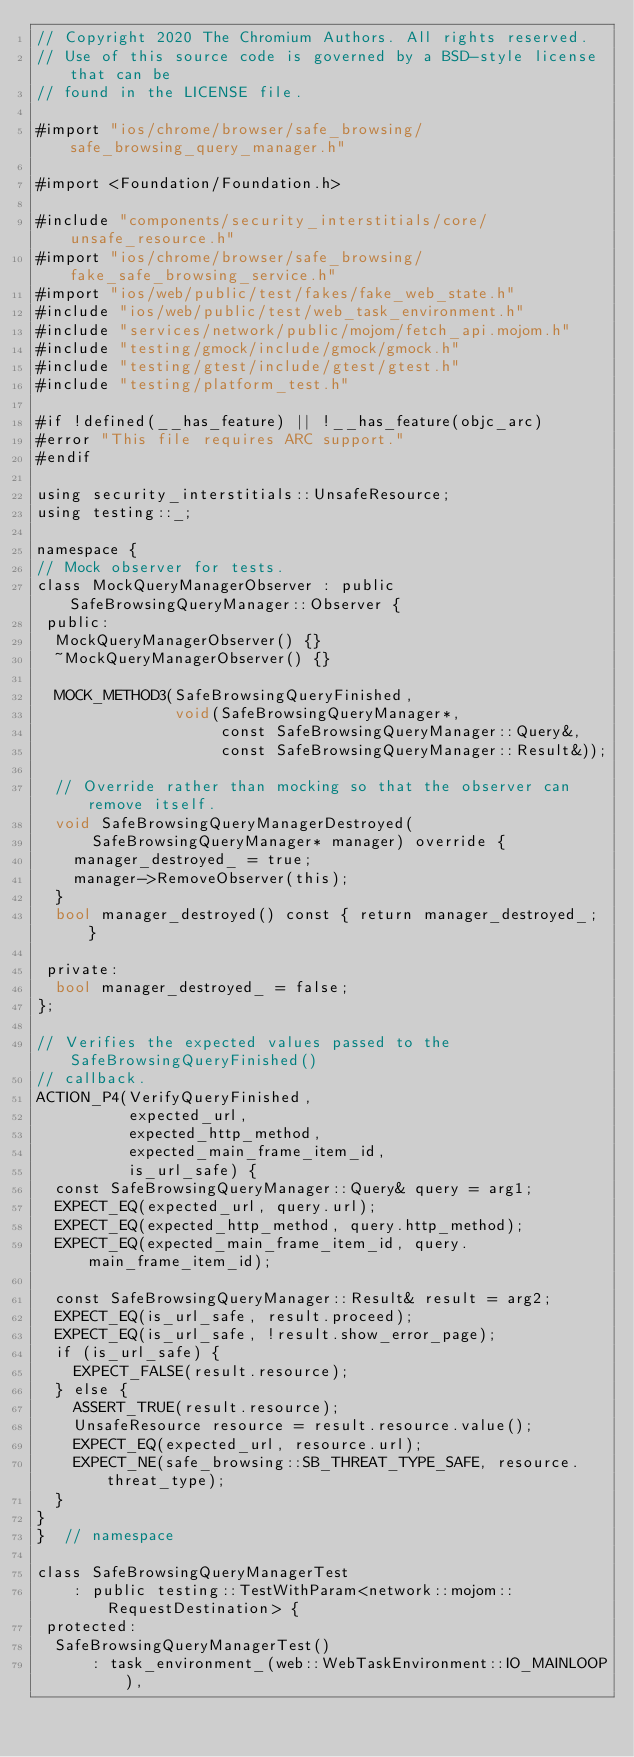Convert code to text. <code><loc_0><loc_0><loc_500><loc_500><_ObjectiveC_>// Copyright 2020 The Chromium Authors. All rights reserved.
// Use of this source code is governed by a BSD-style license that can be
// found in the LICENSE file.

#import "ios/chrome/browser/safe_browsing/safe_browsing_query_manager.h"

#import <Foundation/Foundation.h>

#include "components/security_interstitials/core/unsafe_resource.h"
#import "ios/chrome/browser/safe_browsing/fake_safe_browsing_service.h"
#import "ios/web/public/test/fakes/fake_web_state.h"
#include "ios/web/public/test/web_task_environment.h"
#include "services/network/public/mojom/fetch_api.mojom.h"
#include "testing/gmock/include/gmock/gmock.h"
#include "testing/gtest/include/gtest/gtest.h"
#include "testing/platform_test.h"

#if !defined(__has_feature) || !__has_feature(objc_arc)
#error "This file requires ARC support."
#endif

using security_interstitials::UnsafeResource;
using testing::_;

namespace {
// Mock observer for tests.
class MockQueryManagerObserver : public SafeBrowsingQueryManager::Observer {
 public:
  MockQueryManagerObserver() {}
  ~MockQueryManagerObserver() {}

  MOCK_METHOD3(SafeBrowsingQueryFinished,
               void(SafeBrowsingQueryManager*,
                    const SafeBrowsingQueryManager::Query&,
                    const SafeBrowsingQueryManager::Result&));

  // Override rather than mocking so that the observer can remove itself.
  void SafeBrowsingQueryManagerDestroyed(
      SafeBrowsingQueryManager* manager) override {
    manager_destroyed_ = true;
    manager->RemoveObserver(this);
  }
  bool manager_destroyed() const { return manager_destroyed_; }

 private:
  bool manager_destroyed_ = false;
};

// Verifies the expected values passed to the SafeBrowsingQueryFinished()
// callback.
ACTION_P4(VerifyQueryFinished,
          expected_url,
          expected_http_method,
          expected_main_frame_item_id,
          is_url_safe) {
  const SafeBrowsingQueryManager::Query& query = arg1;
  EXPECT_EQ(expected_url, query.url);
  EXPECT_EQ(expected_http_method, query.http_method);
  EXPECT_EQ(expected_main_frame_item_id, query.main_frame_item_id);

  const SafeBrowsingQueryManager::Result& result = arg2;
  EXPECT_EQ(is_url_safe, result.proceed);
  EXPECT_EQ(is_url_safe, !result.show_error_page);
  if (is_url_safe) {
    EXPECT_FALSE(result.resource);
  } else {
    ASSERT_TRUE(result.resource);
    UnsafeResource resource = result.resource.value();
    EXPECT_EQ(expected_url, resource.url);
    EXPECT_NE(safe_browsing::SB_THREAT_TYPE_SAFE, resource.threat_type);
  }
}
}  // namespace

class SafeBrowsingQueryManagerTest
    : public testing::TestWithParam<network::mojom::RequestDestination> {
 protected:
  SafeBrowsingQueryManagerTest()
      : task_environment_(web::WebTaskEnvironment::IO_MAINLOOP),</code> 